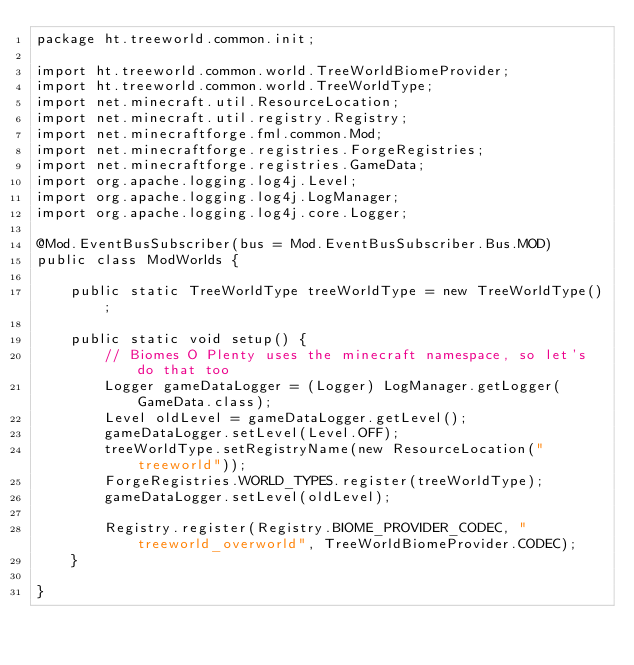<code> <loc_0><loc_0><loc_500><loc_500><_Java_>package ht.treeworld.common.init;

import ht.treeworld.common.world.TreeWorldBiomeProvider;
import ht.treeworld.common.world.TreeWorldType;
import net.minecraft.util.ResourceLocation;
import net.minecraft.util.registry.Registry;
import net.minecraftforge.fml.common.Mod;
import net.minecraftforge.registries.ForgeRegistries;
import net.minecraftforge.registries.GameData;
import org.apache.logging.log4j.Level;
import org.apache.logging.log4j.LogManager;
import org.apache.logging.log4j.core.Logger;

@Mod.EventBusSubscriber(bus = Mod.EventBusSubscriber.Bus.MOD)
public class ModWorlds {

    public static TreeWorldType treeWorldType = new TreeWorldType();

    public static void setup() {
        // Biomes O Plenty uses the minecraft namespace, so let's do that too
        Logger gameDataLogger = (Logger) LogManager.getLogger(GameData.class);
        Level oldLevel = gameDataLogger.getLevel();
        gameDataLogger.setLevel(Level.OFF);
        treeWorldType.setRegistryName(new ResourceLocation("treeworld"));
        ForgeRegistries.WORLD_TYPES.register(treeWorldType);
        gameDataLogger.setLevel(oldLevel);

        Registry.register(Registry.BIOME_PROVIDER_CODEC, "treeworld_overworld", TreeWorldBiomeProvider.CODEC);
    }

}
</code> 